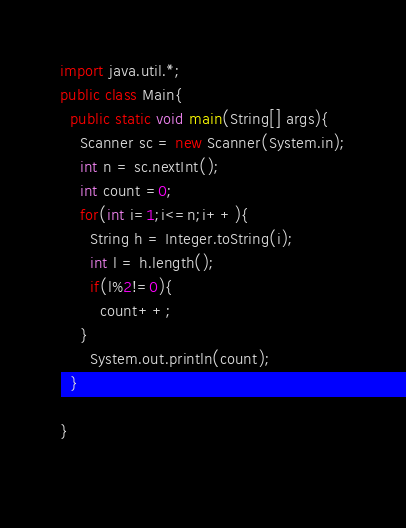Convert code to text. <code><loc_0><loc_0><loc_500><loc_500><_Java_>import java.util.*;
public class Main{
  public static void main(String[] args){
    Scanner sc = new Scanner(System.in);
    int n = sc.nextInt();
    int count =0;
    for(int i=1;i<=n;i++){
      String h = Integer.toString(i);
      int l = h.length();
      if(l%2!=0){
        count++;
    }
      System.out.println(count);
  }
    
}
 </code> 